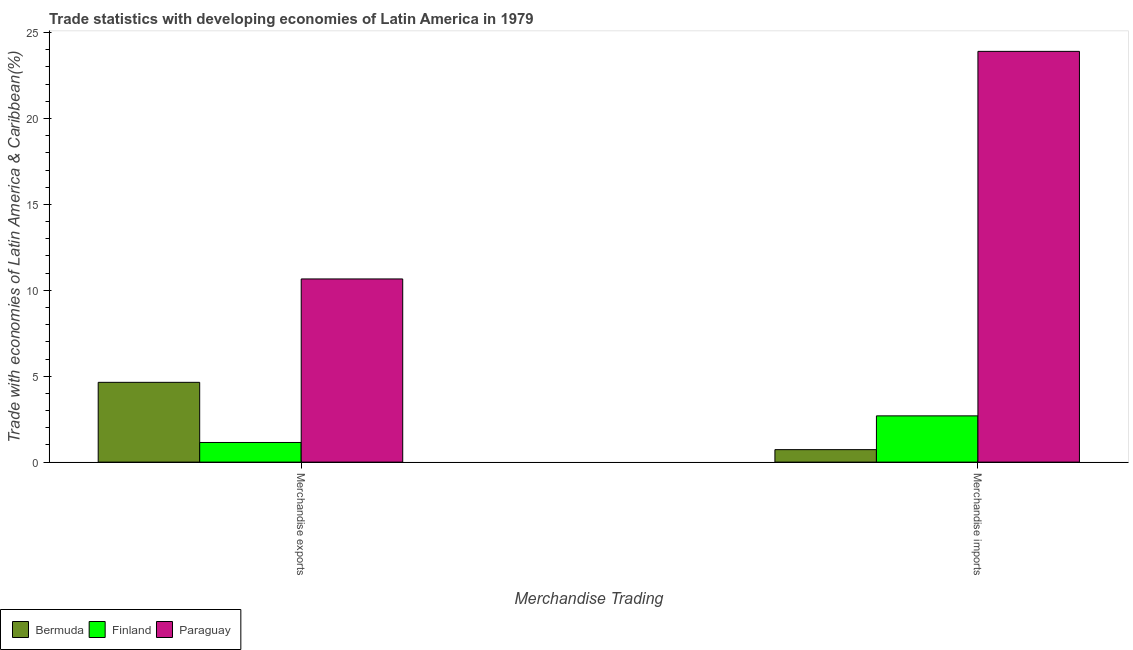How many groups of bars are there?
Provide a short and direct response. 2. Are the number of bars per tick equal to the number of legend labels?
Your answer should be very brief. Yes. Are the number of bars on each tick of the X-axis equal?
Provide a short and direct response. Yes. How many bars are there on the 1st tick from the left?
Provide a short and direct response. 3. What is the label of the 2nd group of bars from the left?
Provide a short and direct response. Merchandise imports. What is the merchandise exports in Finland?
Your response must be concise. 1.14. Across all countries, what is the maximum merchandise exports?
Your answer should be compact. 10.66. Across all countries, what is the minimum merchandise exports?
Provide a succinct answer. 1.14. In which country was the merchandise imports maximum?
Ensure brevity in your answer.  Paraguay. In which country was the merchandise imports minimum?
Your answer should be very brief. Bermuda. What is the total merchandise exports in the graph?
Provide a succinct answer. 16.45. What is the difference between the merchandise imports in Bermuda and that in Finland?
Provide a short and direct response. -1.97. What is the difference between the merchandise imports in Bermuda and the merchandise exports in Paraguay?
Your answer should be very brief. -9.94. What is the average merchandise imports per country?
Your response must be concise. 9.11. What is the difference between the merchandise exports and merchandise imports in Finland?
Make the answer very short. -1.55. In how many countries, is the merchandise exports greater than 12 %?
Offer a very short reply. 0. What is the ratio of the merchandise imports in Finland to that in Bermuda?
Your response must be concise. 3.71. In how many countries, is the merchandise exports greater than the average merchandise exports taken over all countries?
Provide a short and direct response. 1. What does the 1st bar from the left in Merchandise imports represents?
Your answer should be very brief. Bermuda. What does the 3rd bar from the right in Merchandise imports represents?
Your answer should be very brief. Bermuda. Are all the bars in the graph horizontal?
Provide a short and direct response. No. How many countries are there in the graph?
Your response must be concise. 3. Are the values on the major ticks of Y-axis written in scientific E-notation?
Your answer should be very brief. No. Does the graph contain any zero values?
Offer a very short reply. No. Where does the legend appear in the graph?
Your answer should be compact. Bottom left. How many legend labels are there?
Ensure brevity in your answer.  3. What is the title of the graph?
Offer a terse response. Trade statistics with developing economies of Latin America in 1979. What is the label or title of the X-axis?
Your answer should be very brief. Merchandise Trading. What is the label or title of the Y-axis?
Your response must be concise. Trade with economies of Latin America & Caribbean(%). What is the Trade with economies of Latin America & Caribbean(%) of Bermuda in Merchandise exports?
Keep it short and to the point. 4.64. What is the Trade with economies of Latin America & Caribbean(%) in Finland in Merchandise exports?
Give a very brief answer. 1.14. What is the Trade with economies of Latin America & Caribbean(%) in Paraguay in Merchandise exports?
Your answer should be very brief. 10.66. What is the Trade with economies of Latin America & Caribbean(%) in Bermuda in Merchandise imports?
Your answer should be compact. 0.73. What is the Trade with economies of Latin America & Caribbean(%) in Finland in Merchandise imports?
Provide a short and direct response. 2.69. What is the Trade with economies of Latin America & Caribbean(%) in Paraguay in Merchandise imports?
Provide a short and direct response. 23.91. Across all Merchandise Trading, what is the maximum Trade with economies of Latin America & Caribbean(%) of Bermuda?
Offer a very short reply. 4.64. Across all Merchandise Trading, what is the maximum Trade with economies of Latin America & Caribbean(%) of Finland?
Offer a terse response. 2.69. Across all Merchandise Trading, what is the maximum Trade with economies of Latin America & Caribbean(%) of Paraguay?
Make the answer very short. 23.91. Across all Merchandise Trading, what is the minimum Trade with economies of Latin America & Caribbean(%) in Bermuda?
Your answer should be compact. 0.73. Across all Merchandise Trading, what is the minimum Trade with economies of Latin America & Caribbean(%) in Finland?
Provide a succinct answer. 1.14. Across all Merchandise Trading, what is the minimum Trade with economies of Latin America & Caribbean(%) of Paraguay?
Keep it short and to the point. 10.66. What is the total Trade with economies of Latin America & Caribbean(%) in Bermuda in the graph?
Offer a very short reply. 5.37. What is the total Trade with economies of Latin America & Caribbean(%) of Finland in the graph?
Keep it short and to the point. 3.84. What is the total Trade with economies of Latin America & Caribbean(%) of Paraguay in the graph?
Your response must be concise. 34.57. What is the difference between the Trade with economies of Latin America & Caribbean(%) in Bermuda in Merchandise exports and that in Merchandise imports?
Your answer should be compact. 3.92. What is the difference between the Trade with economies of Latin America & Caribbean(%) in Finland in Merchandise exports and that in Merchandise imports?
Provide a succinct answer. -1.55. What is the difference between the Trade with economies of Latin America & Caribbean(%) in Paraguay in Merchandise exports and that in Merchandise imports?
Your answer should be very brief. -13.25. What is the difference between the Trade with economies of Latin America & Caribbean(%) of Bermuda in Merchandise exports and the Trade with economies of Latin America & Caribbean(%) of Finland in Merchandise imports?
Keep it short and to the point. 1.95. What is the difference between the Trade with economies of Latin America & Caribbean(%) of Bermuda in Merchandise exports and the Trade with economies of Latin America & Caribbean(%) of Paraguay in Merchandise imports?
Offer a very short reply. -19.27. What is the difference between the Trade with economies of Latin America & Caribbean(%) of Finland in Merchandise exports and the Trade with economies of Latin America & Caribbean(%) of Paraguay in Merchandise imports?
Keep it short and to the point. -22.77. What is the average Trade with economies of Latin America & Caribbean(%) in Bermuda per Merchandise Trading?
Your answer should be compact. 2.69. What is the average Trade with economies of Latin America & Caribbean(%) in Finland per Merchandise Trading?
Make the answer very short. 1.92. What is the average Trade with economies of Latin America & Caribbean(%) of Paraguay per Merchandise Trading?
Ensure brevity in your answer.  17.29. What is the difference between the Trade with economies of Latin America & Caribbean(%) in Bermuda and Trade with economies of Latin America & Caribbean(%) in Finland in Merchandise exports?
Offer a very short reply. 3.5. What is the difference between the Trade with economies of Latin America & Caribbean(%) of Bermuda and Trade with economies of Latin America & Caribbean(%) of Paraguay in Merchandise exports?
Provide a short and direct response. -6.02. What is the difference between the Trade with economies of Latin America & Caribbean(%) in Finland and Trade with economies of Latin America & Caribbean(%) in Paraguay in Merchandise exports?
Provide a short and direct response. -9.52. What is the difference between the Trade with economies of Latin America & Caribbean(%) in Bermuda and Trade with economies of Latin America & Caribbean(%) in Finland in Merchandise imports?
Your answer should be compact. -1.97. What is the difference between the Trade with economies of Latin America & Caribbean(%) in Bermuda and Trade with economies of Latin America & Caribbean(%) in Paraguay in Merchandise imports?
Make the answer very short. -23.18. What is the difference between the Trade with economies of Latin America & Caribbean(%) in Finland and Trade with economies of Latin America & Caribbean(%) in Paraguay in Merchandise imports?
Your answer should be compact. -21.22. What is the ratio of the Trade with economies of Latin America & Caribbean(%) of Bermuda in Merchandise exports to that in Merchandise imports?
Keep it short and to the point. 6.39. What is the ratio of the Trade with economies of Latin America & Caribbean(%) in Finland in Merchandise exports to that in Merchandise imports?
Your answer should be very brief. 0.42. What is the ratio of the Trade with economies of Latin America & Caribbean(%) in Paraguay in Merchandise exports to that in Merchandise imports?
Give a very brief answer. 0.45. What is the difference between the highest and the second highest Trade with economies of Latin America & Caribbean(%) in Bermuda?
Your answer should be compact. 3.92. What is the difference between the highest and the second highest Trade with economies of Latin America & Caribbean(%) of Finland?
Give a very brief answer. 1.55. What is the difference between the highest and the second highest Trade with economies of Latin America & Caribbean(%) in Paraguay?
Ensure brevity in your answer.  13.25. What is the difference between the highest and the lowest Trade with economies of Latin America & Caribbean(%) of Bermuda?
Provide a succinct answer. 3.92. What is the difference between the highest and the lowest Trade with economies of Latin America & Caribbean(%) in Finland?
Your response must be concise. 1.55. What is the difference between the highest and the lowest Trade with economies of Latin America & Caribbean(%) of Paraguay?
Give a very brief answer. 13.25. 